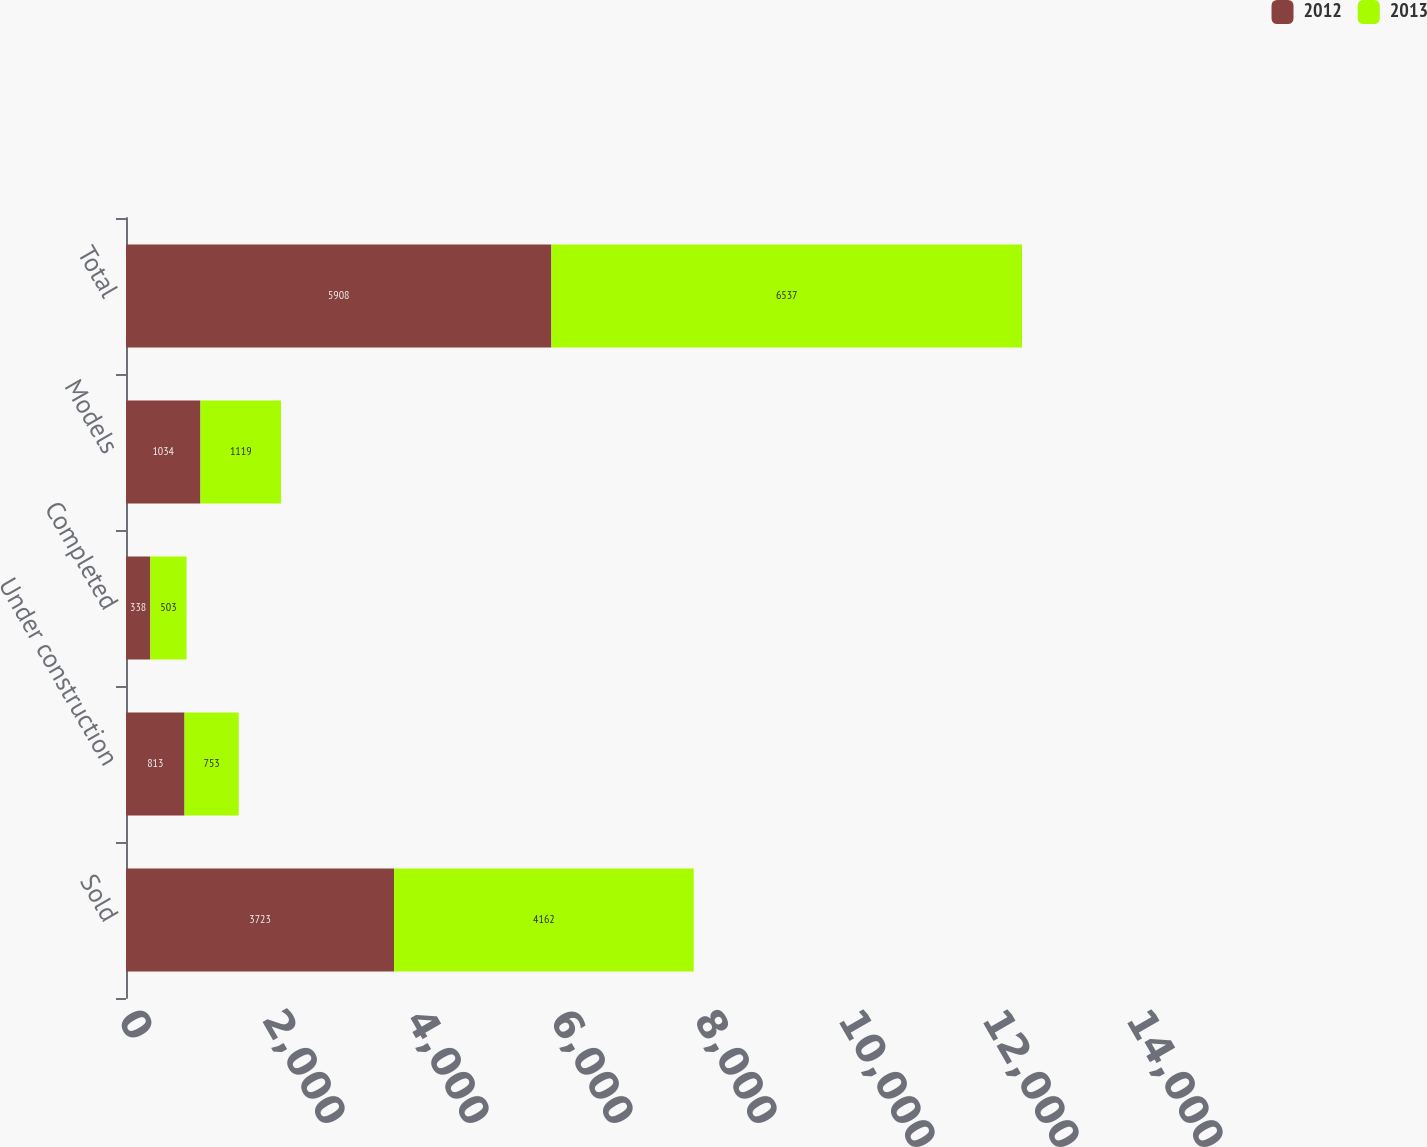Convert chart. <chart><loc_0><loc_0><loc_500><loc_500><stacked_bar_chart><ecel><fcel>Sold<fcel>Under construction<fcel>Completed<fcel>Models<fcel>Total<nl><fcel>2012<fcel>3723<fcel>813<fcel>338<fcel>1034<fcel>5908<nl><fcel>2013<fcel>4162<fcel>753<fcel>503<fcel>1119<fcel>6537<nl></chart> 